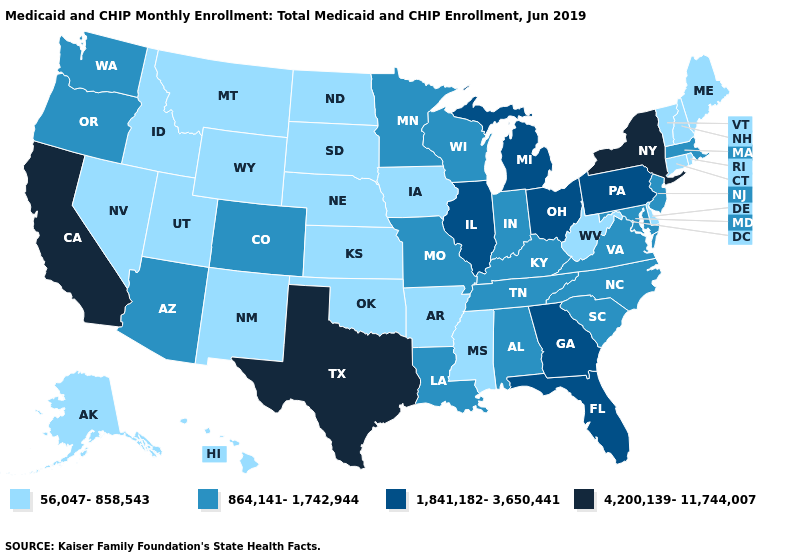What is the lowest value in states that border North Dakota?
Write a very short answer. 56,047-858,543. What is the lowest value in the USA?
Give a very brief answer. 56,047-858,543. What is the value of California?
Answer briefly. 4,200,139-11,744,007. Among the states that border Texas , which have the highest value?
Give a very brief answer. Louisiana. What is the highest value in the MidWest ?
Concise answer only. 1,841,182-3,650,441. What is the value of Virginia?
Short answer required. 864,141-1,742,944. Among the states that border Georgia , does Tennessee have the highest value?
Write a very short answer. No. Name the states that have a value in the range 1,841,182-3,650,441?
Concise answer only. Florida, Georgia, Illinois, Michigan, Ohio, Pennsylvania. Which states have the lowest value in the USA?
Give a very brief answer. Alaska, Arkansas, Connecticut, Delaware, Hawaii, Idaho, Iowa, Kansas, Maine, Mississippi, Montana, Nebraska, Nevada, New Hampshire, New Mexico, North Dakota, Oklahoma, Rhode Island, South Dakota, Utah, Vermont, West Virginia, Wyoming. What is the highest value in states that border West Virginia?
Keep it brief. 1,841,182-3,650,441. Which states have the lowest value in the USA?
Be succinct. Alaska, Arkansas, Connecticut, Delaware, Hawaii, Idaho, Iowa, Kansas, Maine, Mississippi, Montana, Nebraska, Nevada, New Hampshire, New Mexico, North Dakota, Oklahoma, Rhode Island, South Dakota, Utah, Vermont, West Virginia, Wyoming. Does Virginia have the lowest value in the USA?
Quick response, please. No. Name the states that have a value in the range 56,047-858,543?
Be succinct. Alaska, Arkansas, Connecticut, Delaware, Hawaii, Idaho, Iowa, Kansas, Maine, Mississippi, Montana, Nebraska, Nevada, New Hampshire, New Mexico, North Dakota, Oklahoma, Rhode Island, South Dakota, Utah, Vermont, West Virginia, Wyoming. Which states hav the highest value in the MidWest?
Be succinct. Illinois, Michigan, Ohio. Among the states that border New Jersey , which have the lowest value?
Be succinct. Delaware. 